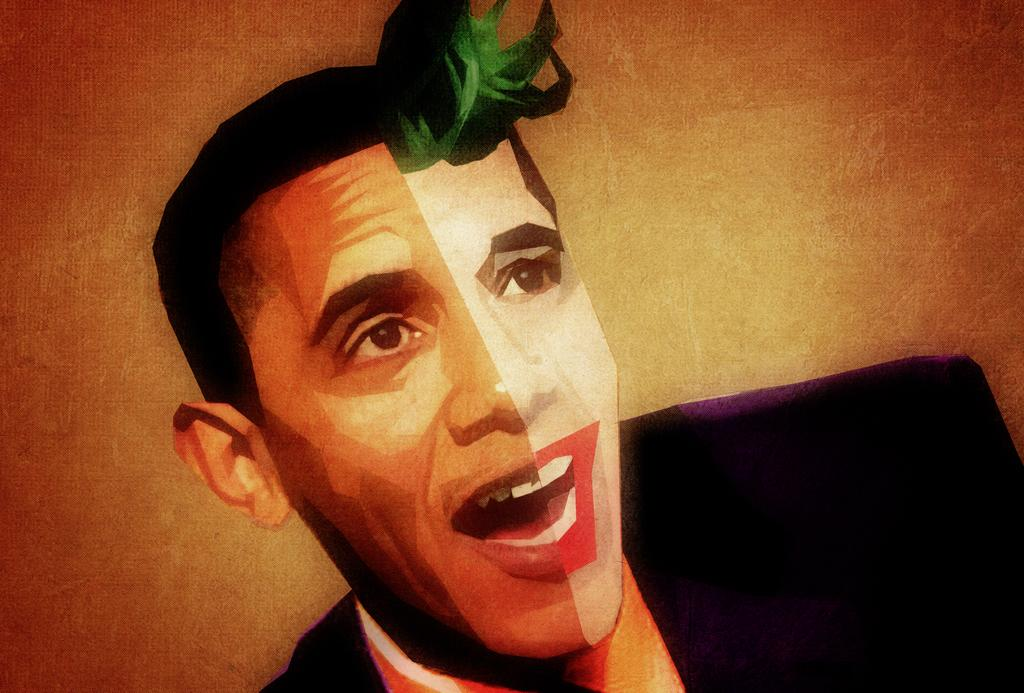What is the main subject of the image? There is a picture of a man in the image. What is the man wearing in the image? The man is wearing a black color shirt in the image. What colors can be seen in the background of the image? There is a green color and an orange color in the background of the image. Can you see a cat playing with ink in the image? There is no cat or ink present in the image. 